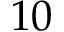Convert formula to latex. <formula><loc_0><loc_0><loc_500><loc_500>1 0</formula> 